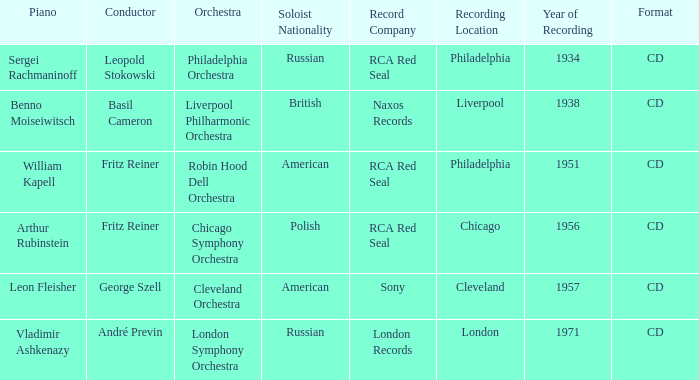Which orchestra has a recording year of 1951? Robin Hood Dell Orchestra. 